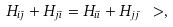Convert formula to latex. <formula><loc_0><loc_0><loc_500><loc_500>H _ { i \bar { \jmath } } + H _ { j \bar { \imath } } = H _ { i \bar { \imath } } + H _ { j \bar { \jmath } } \ > ,</formula> 